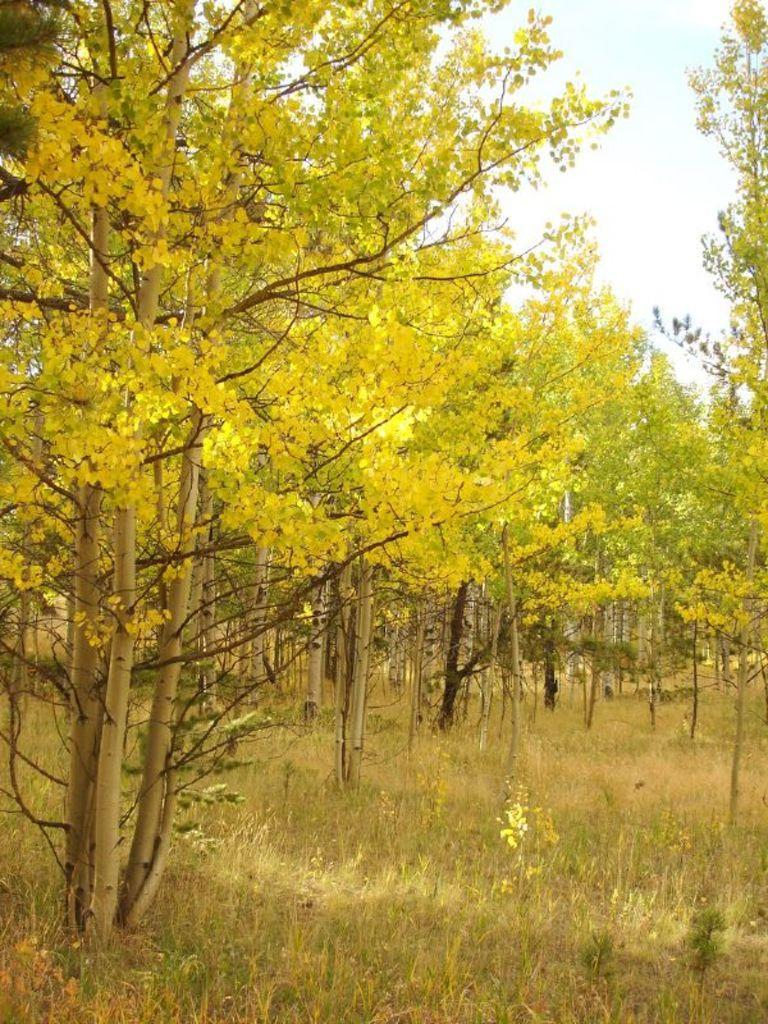What type of vegetation can be seen in the image? There are trees in the image. What else can be seen on the ground in the image? There is grass in the image. What is visible in the background of the image? The sky is visible in the background of the image. What type of headwear is the tree wearing in the image? There are no trees wearing headwear in the image, as trees do not wear clothing or accessories. 